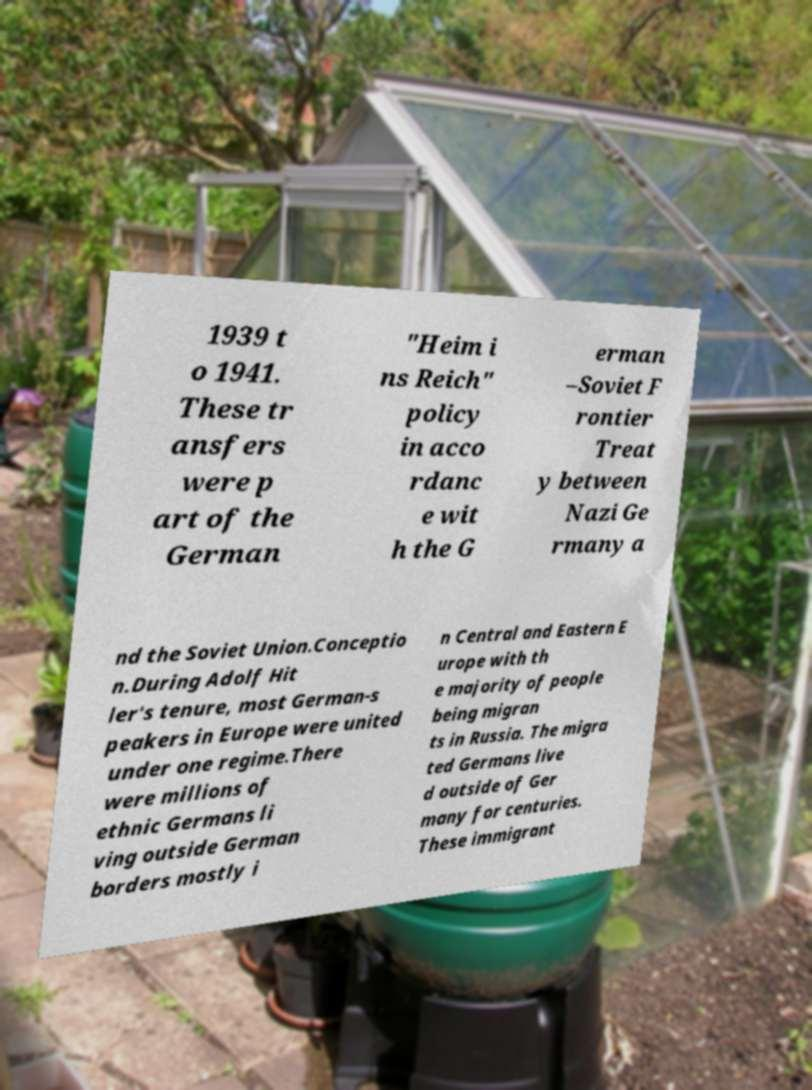Could you assist in decoding the text presented in this image and type it out clearly? 1939 t o 1941. These tr ansfers were p art of the German "Heim i ns Reich" policy in acco rdanc e wit h the G erman –Soviet F rontier Treat y between Nazi Ge rmany a nd the Soviet Union.Conceptio n.During Adolf Hit ler's tenure, most German-s peakers in Europe were united under one regime.There were millions of ethnic Germans li ving outside German borders mostly i n Central and Eastern E urope with th e majority of people being migran ts in Russia. The migra ted Germans live d outside of Ger many for centuries. These immigrant 